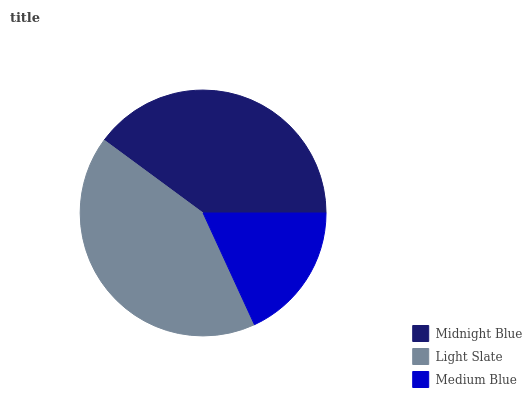Is Medium Blue the minimum?
Answer yes or no. Yes. Is Light Slate the maximum?
Answer yes or no. Yes. Is Light Slate the minimum?
Answer yes or no. No. Is Medium Blue the maximum?
Answer yes or no. No. Is Light Slate greater than Medium Blue?
Answer yes or no. Yes. Is Medium Blue less than Light Slate?
Answer yes or no. Yes. Is Medium Blue greater than Light Slate?
Answer yes or no. No. Is Light Slate less than Medium Blue?
Answer yes or no. No. Is Midnight Blue the high median?
Answer yes or no. Yes. Is Midnight Blue the low median?
Answer yes or no. Yes. Is Light Slate the high median?
Answer yes or no. No. Is Light Slate the low median?
Answer yes or no. No. 